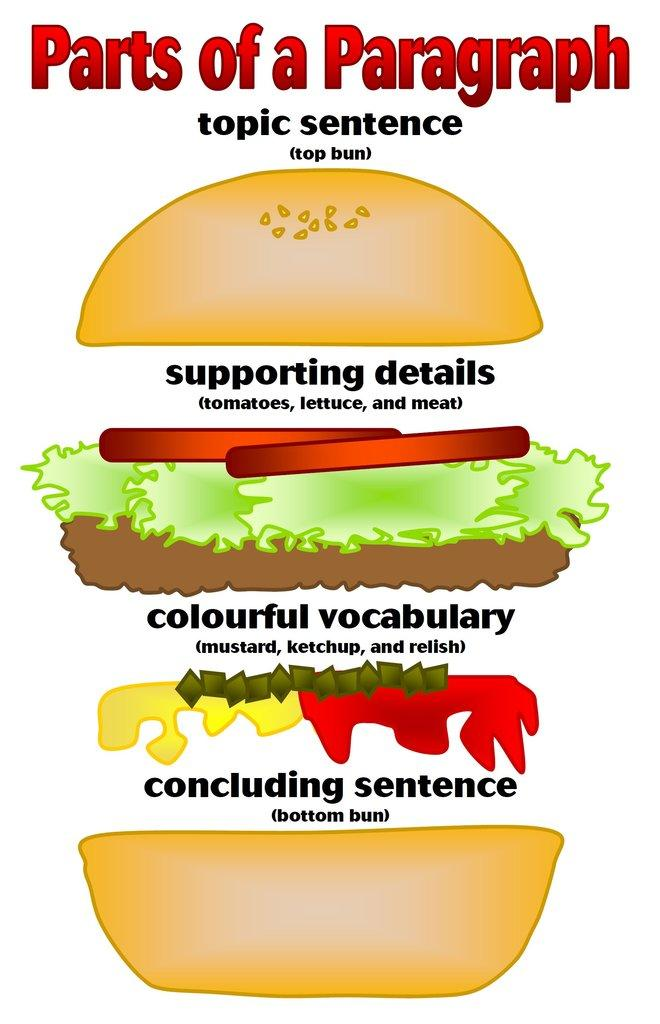What is depicted on the poster in the image? The poster features a burger. What else can be seen on the poster besides the burger? There is writing on the poster. What is the income of the person who created the poster in the image? There is no information about the income of the person who created the poster in the image. What territory is depicted on the poster? The poster features a burger, not a territory. 